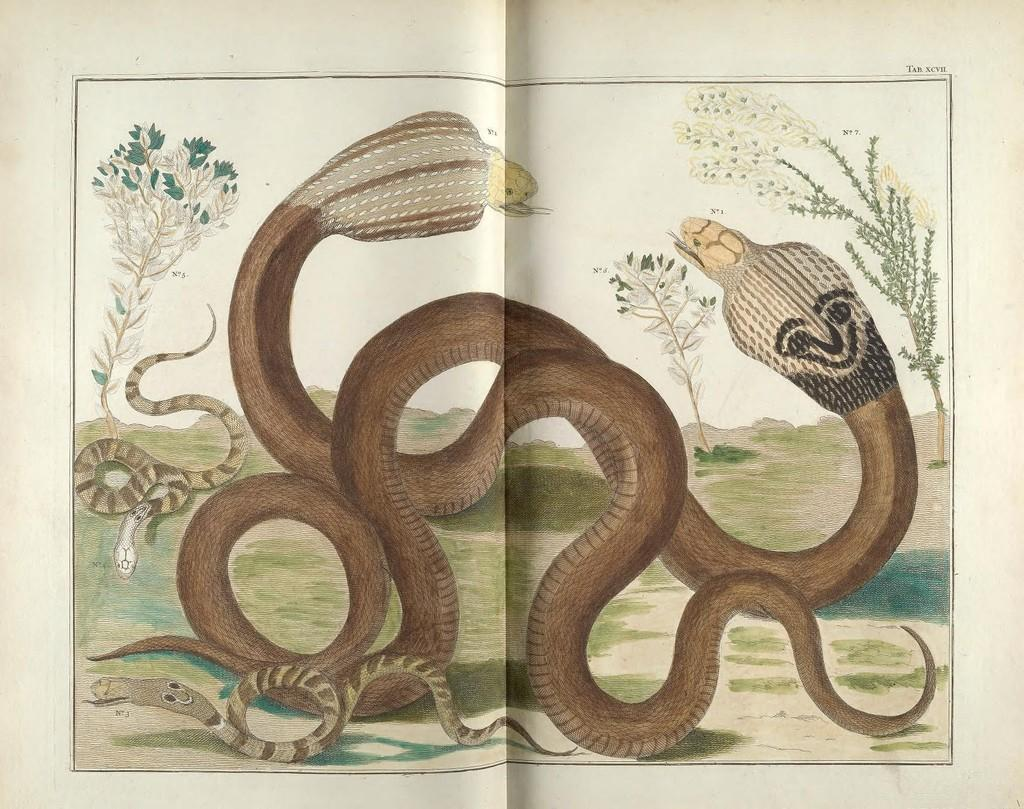What type of visual is the image? The image is a poster. What creatures are featured on the poster? There are snakes depicted on the poster. What can be seen in the background of the poster? There are plants visible in the background of the poster. Where is the book placed on the table in the image? There is no table or book present in the image; it features a poster with snakes and plants in the background. 